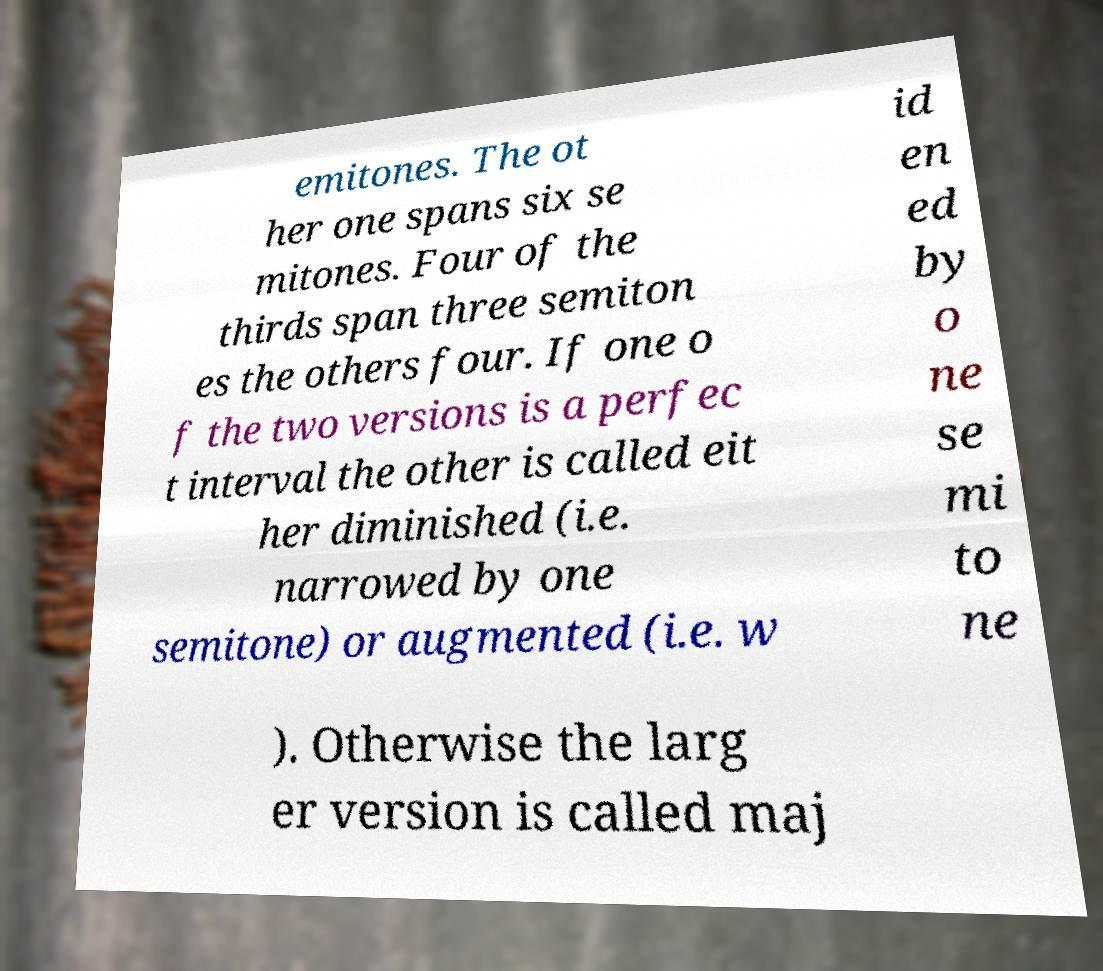Please identify and transcribe the text found in this image. emitones. The ot her one spans six se mitones. Four of the thirds span three semiton es the others four. If one o f the two versions is a perfec t interval the other is called eit her diminished (i.e. narrowed by one semitone) or augmented (i.e. w id en ed by o ne se mi to ne ). Otherwise the larg er version is called maj 